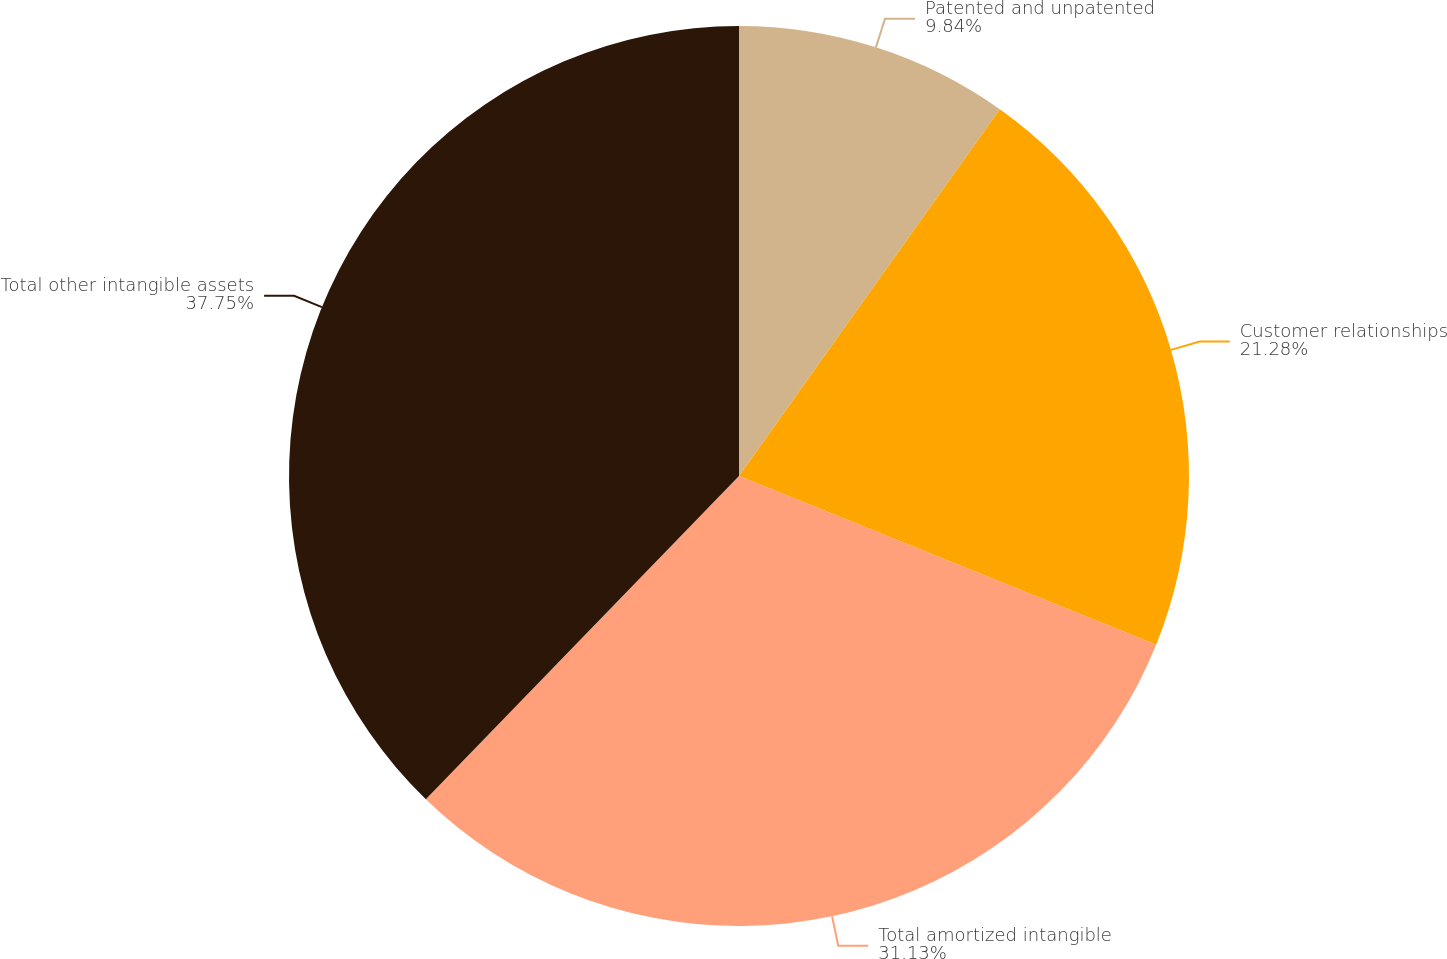<chart> <loc_0><loc_0><loc_500><loc_500><pie_chart><fcel>Patented and unpatented<fcel>Customer relationships<fcel>Total amortized intangible<fcel>Total other intangible assets<nl><fcel>9.84%<fcel>21.28%<fcel>31.13%<fcel>37.75%<nl></chart> 